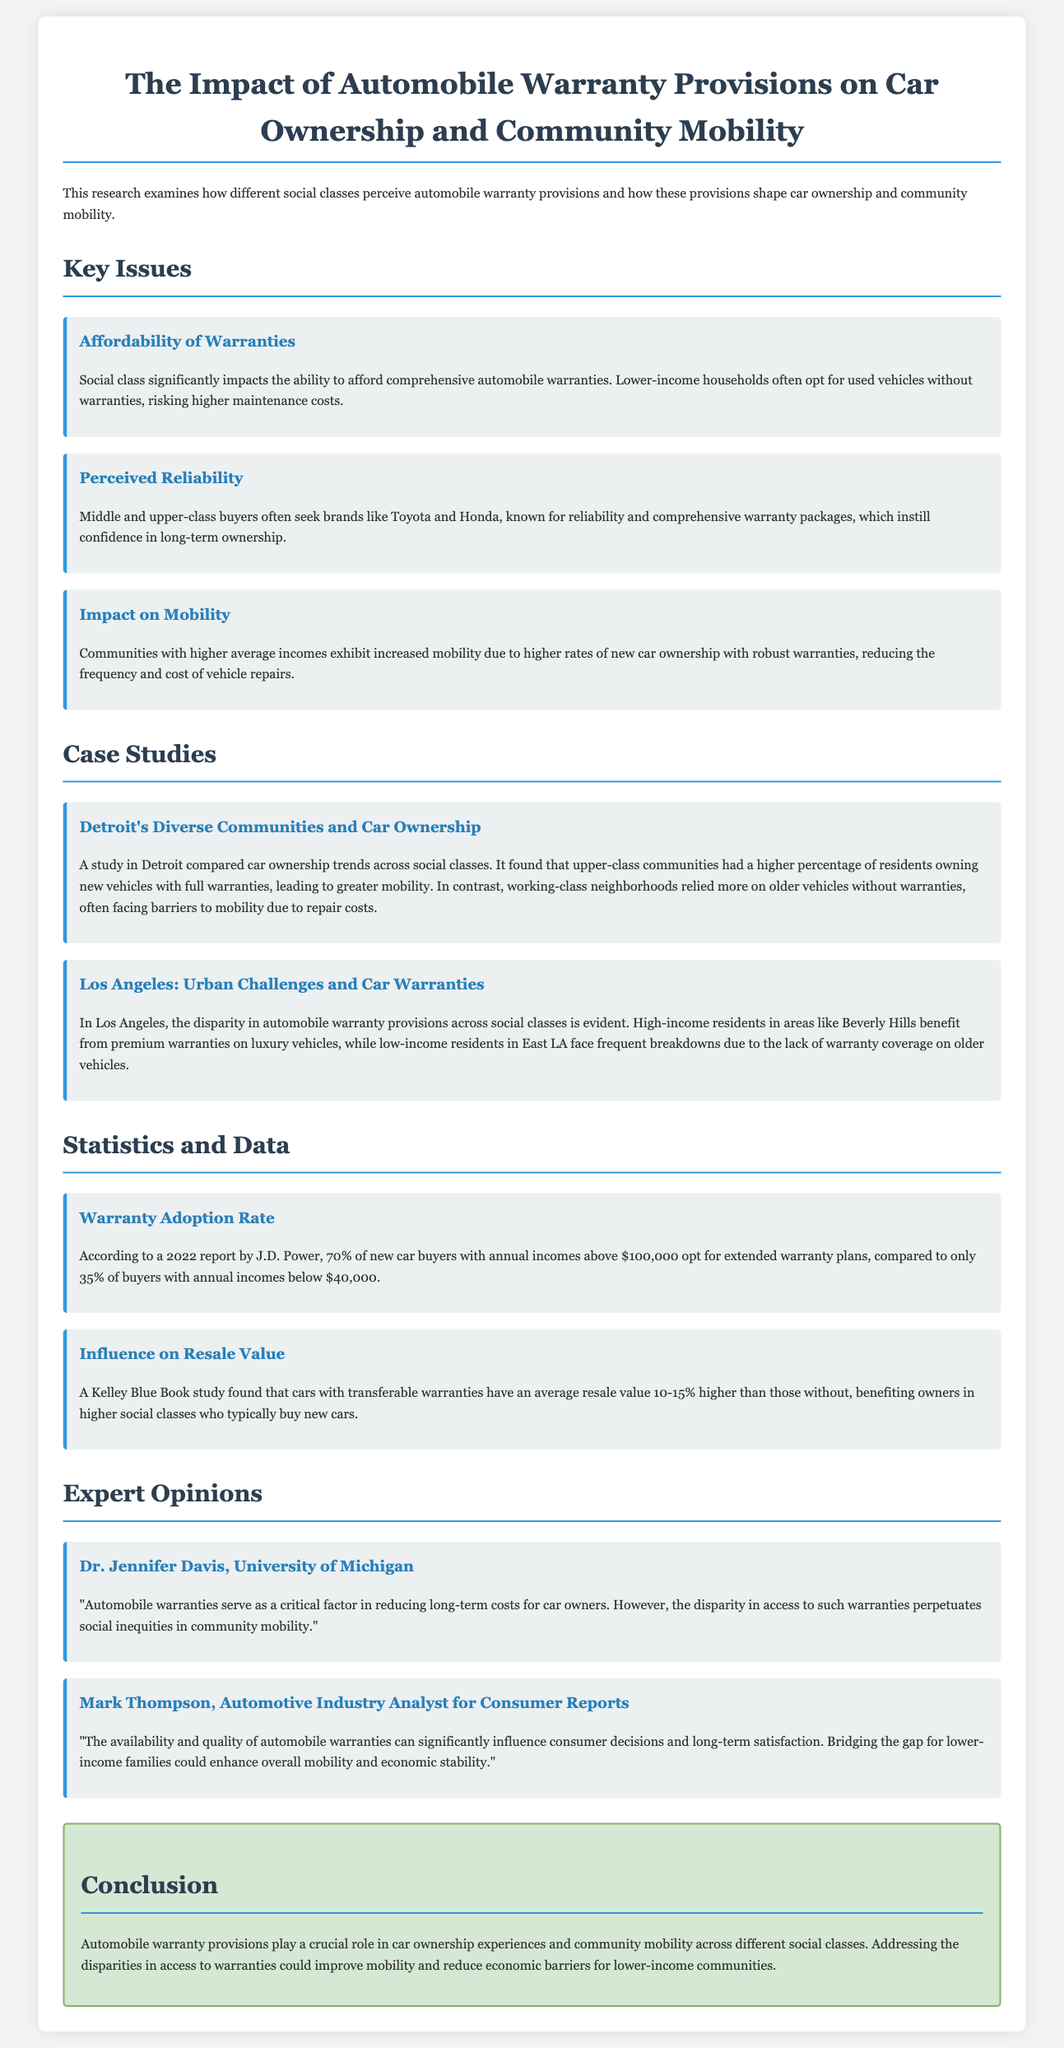What is the main title of the document? The main title provides the focus of the research on automobile warranties and their effects on mobility.
Answer: The Impact of Automobile Warranty Provisions on Car Ownership and Community Mobility What percentage of new car buyers with incomes above $100,000 opt for extended warranty plans? This statistic highlights the financial capability of higher-income buyers to invest in warranties.
Answer: 70% Which social class tends to rely more on older vehicles without warranties? This indicates the economic challenges faced by this group in accessing vehicle maintenance.
Answer: Working-class What is a recommended brand known for reliability that middle and upper-class buyers often seek? This brand association reflects consumer preferences in seeking assurance of vehicle performance.
Answer: Toyota Who conducted the case study in Detroit? This attribution provides credibility and context to the findings shared in the document.
Answer: The document does not state a specific individual or organization for the Detroit study What is a key factor Dr. Jennifer Davis identifies regarding automobile warranties? This highlights the social implications of warranty access related to mobility.
Answer: Reducing long-term costs What is the difference in warranty adoption rates between high-income and low-income buyers? This contrasts the behaviors of different social classes regarding warranties.
Answer: 35% In which community are high-income residents benefiting from premium warranties? This specifies a geographic area demonstrating warranty disparities.
Answer: Beverly Hills What effect do transferable warranties have on resale value? This links the type of warranty to economic benefits for car owners.
Answer: 10-15% higher 